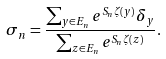<formula> <loc_0><loc_0><loc_500><loc_500>\sigma _ { n } = \frac { \sum _ { y \in E _ { n } } e ^ { S _ { n } \zeta ( y ) } \delta _ { y } } { \sum _ { z \in E _ { n } } e ^ { S _ { n } \zeta ( z ) } } .</formula> 